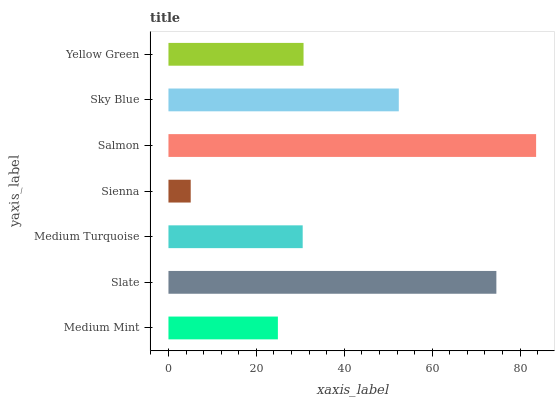Is Sienna the minimum?
Answer yes or no. Yes. Is Salmon the maximum?
Answer yes or no. Yes. Is Slate the minimum?
Answer yes or no. No. Is Slate the maximum?
Answer yes or no. No. Is Slate greater than Medium Mint?
Answer yes or no. Yes. Is Medium Mint less than Slate?
Answer yes or no. Yes. Is Medium Mint greater than Slate?
Answer yes or no. No. Is Slate less than Medium Mint?
Answer yes or no. No. Is Yellow Green the high median?
Answer yes or no. Yes. Is Yellow Green the low median?
Answer yes or no. Yes. Is Sienna the high median?
Answer yes or no. No. Is Slate the low median?
Answer yes or no. No. 